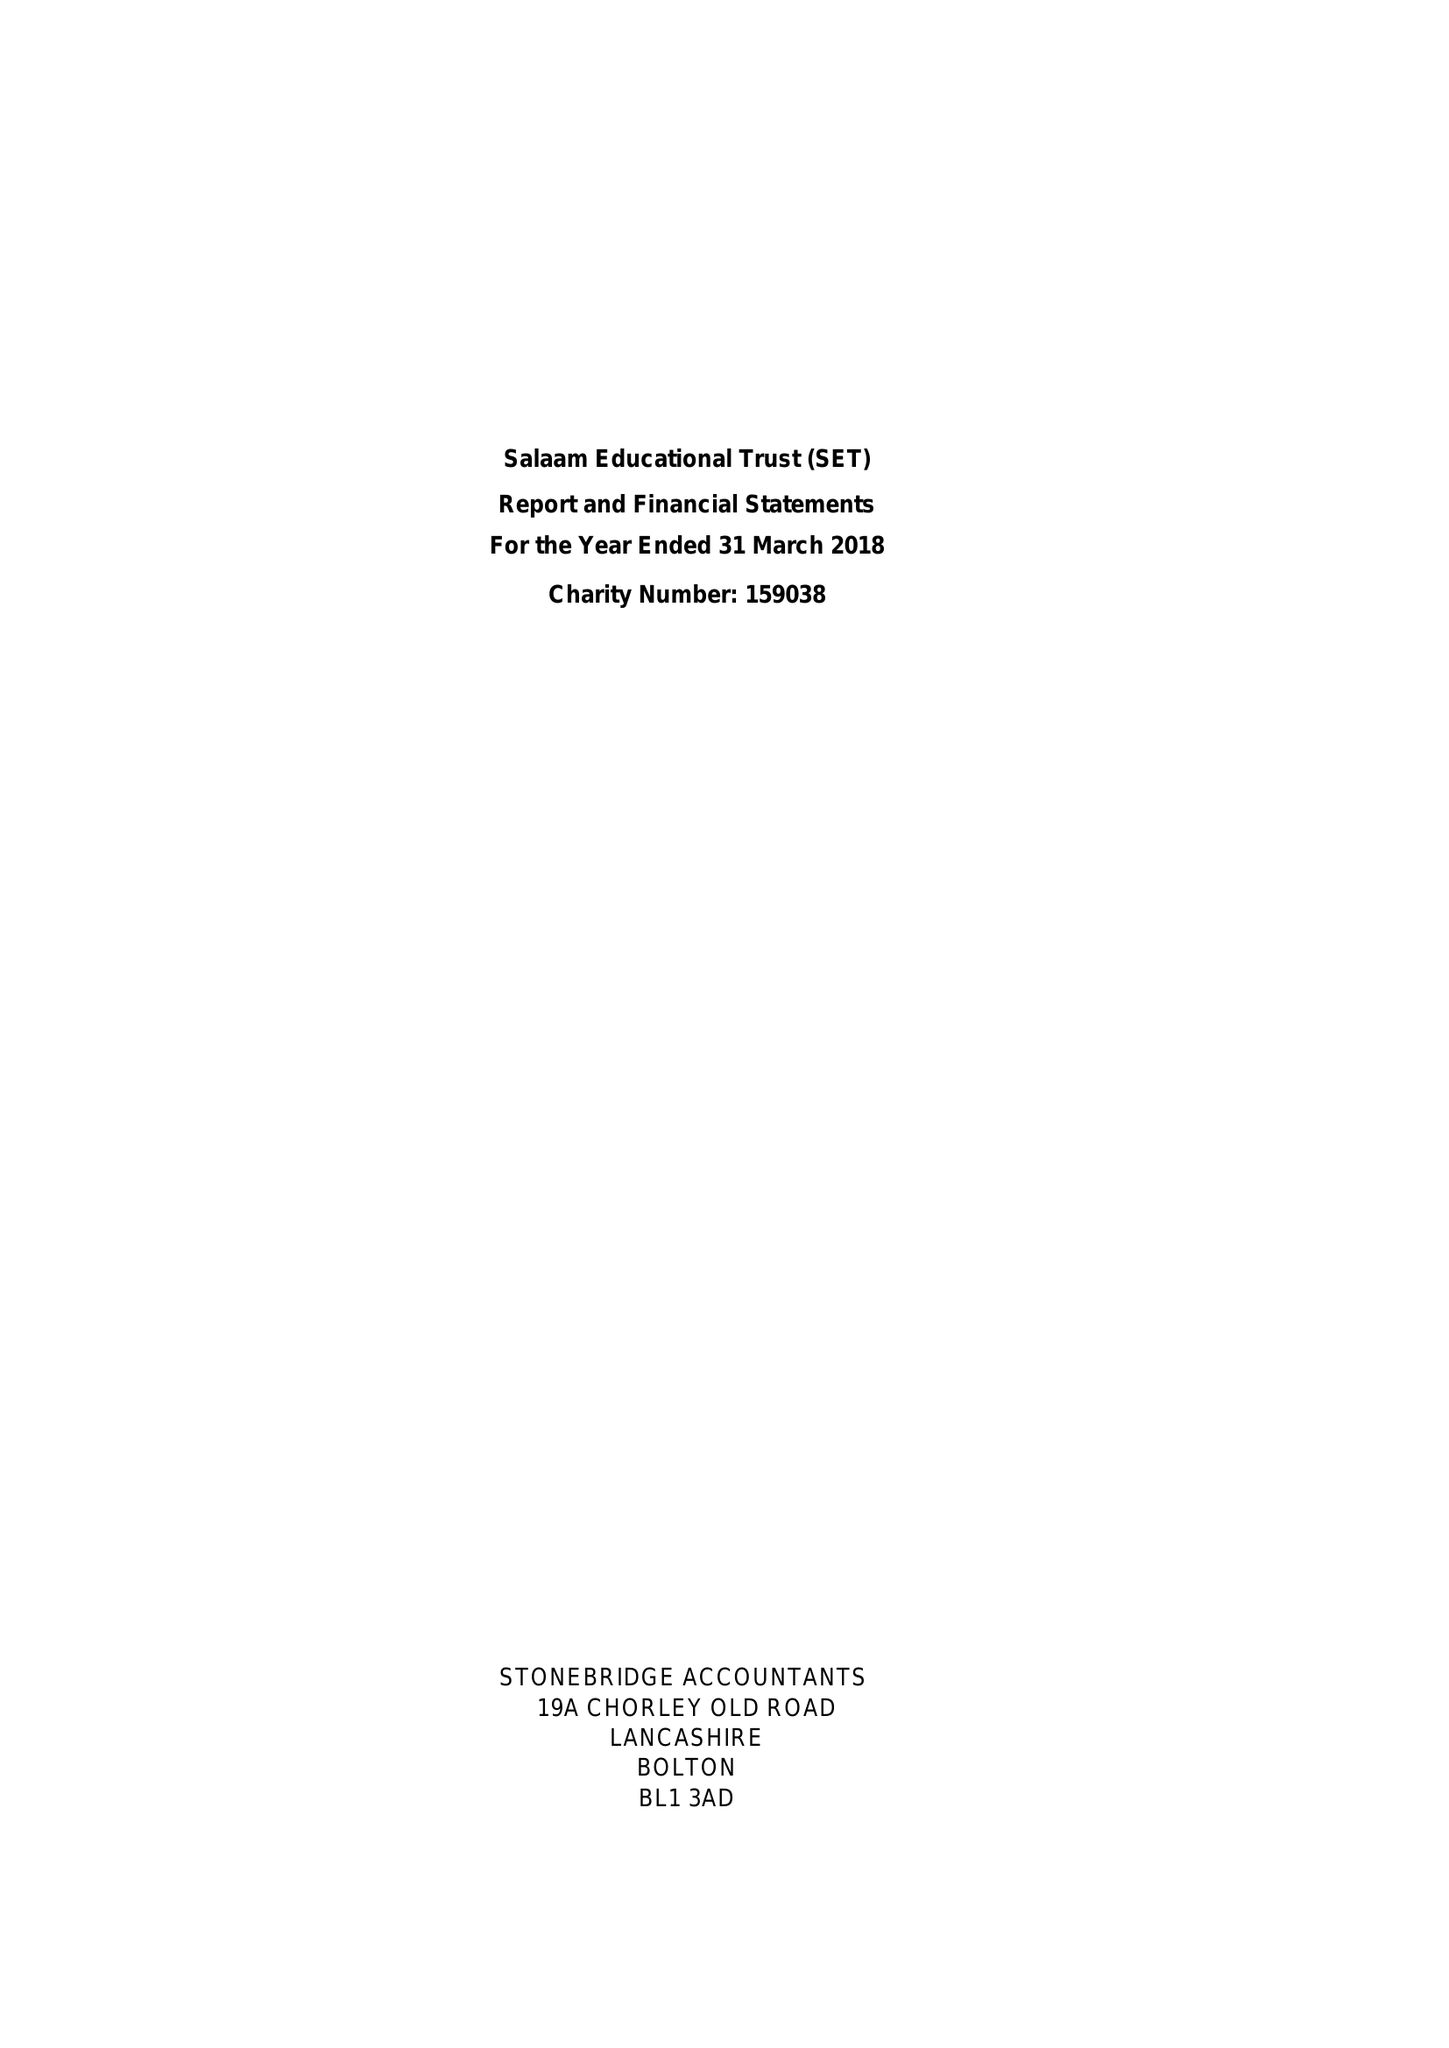What is the value for the address__street_line?
Answer the question using a single word or phrase. 32A WATLING STREET ROAD 